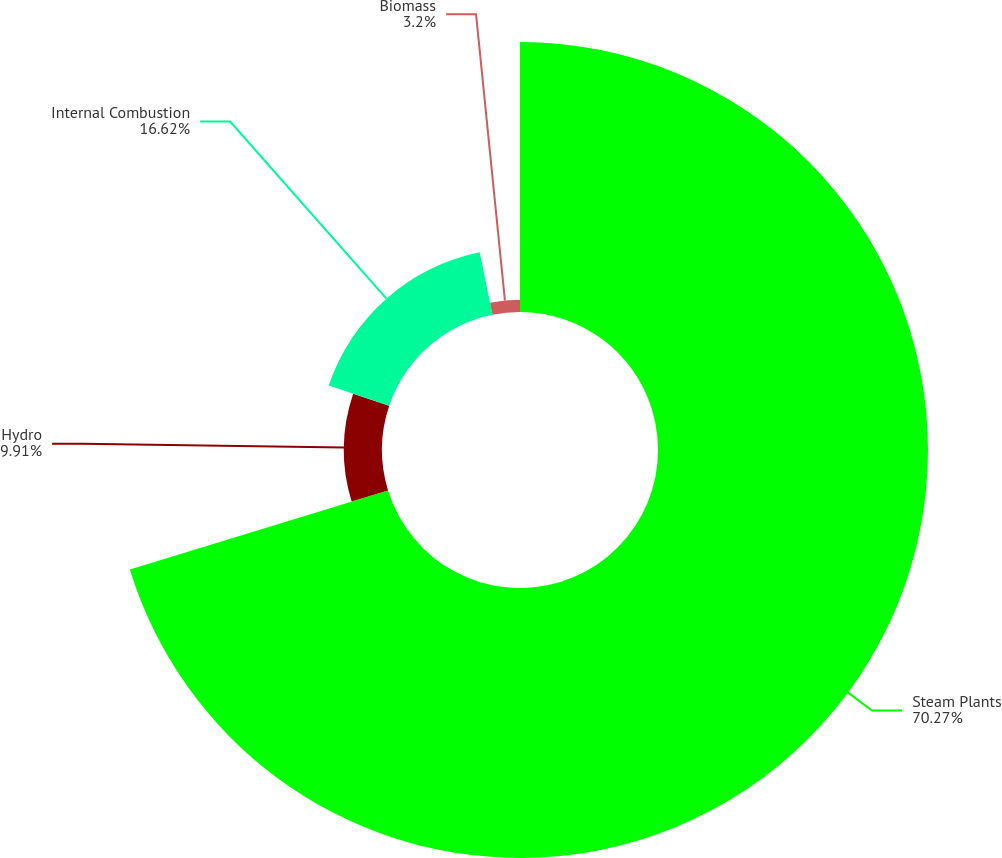Convert chart. <chart><loc_0><loc_0><loc_500><loc_500><pie_chart><fcel>Steam Plants<fcel>Hydro<fcel>Internal Combustion<fcel>Biomass<nl><fcel>70.28%<fcel>9.91%<fcel>16.62%<fcel>3.2%<nl></chart> 